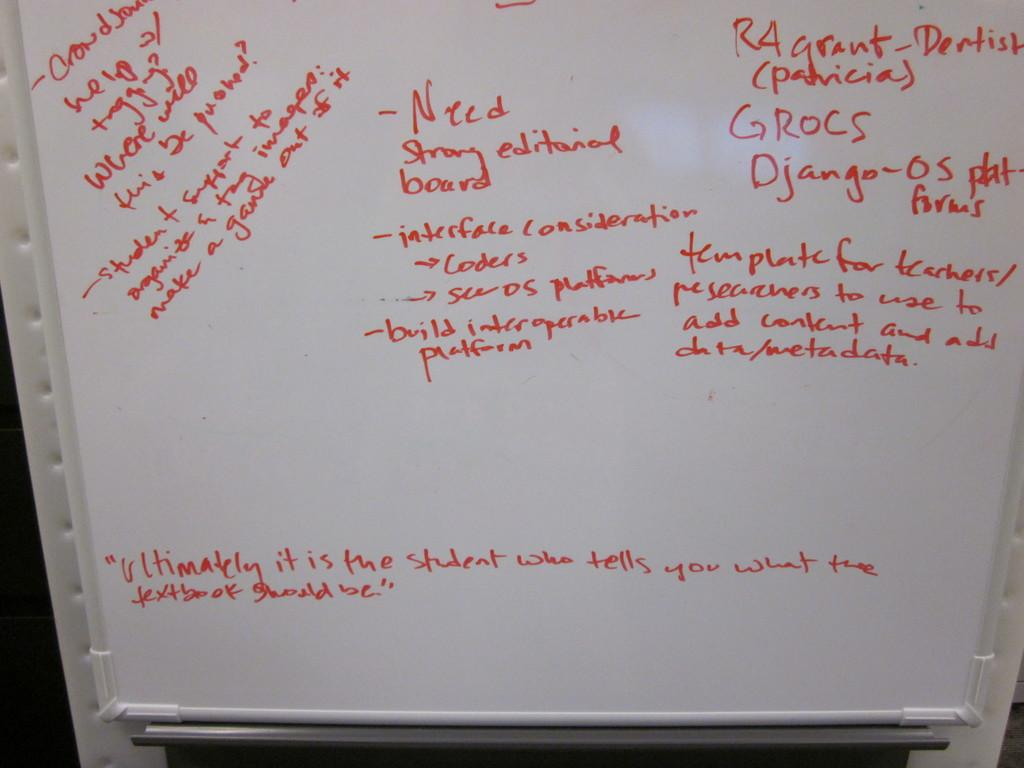<image>
Describe the image concisely. A whiteboard which has a quote at the bottom that starts with ultimately. 